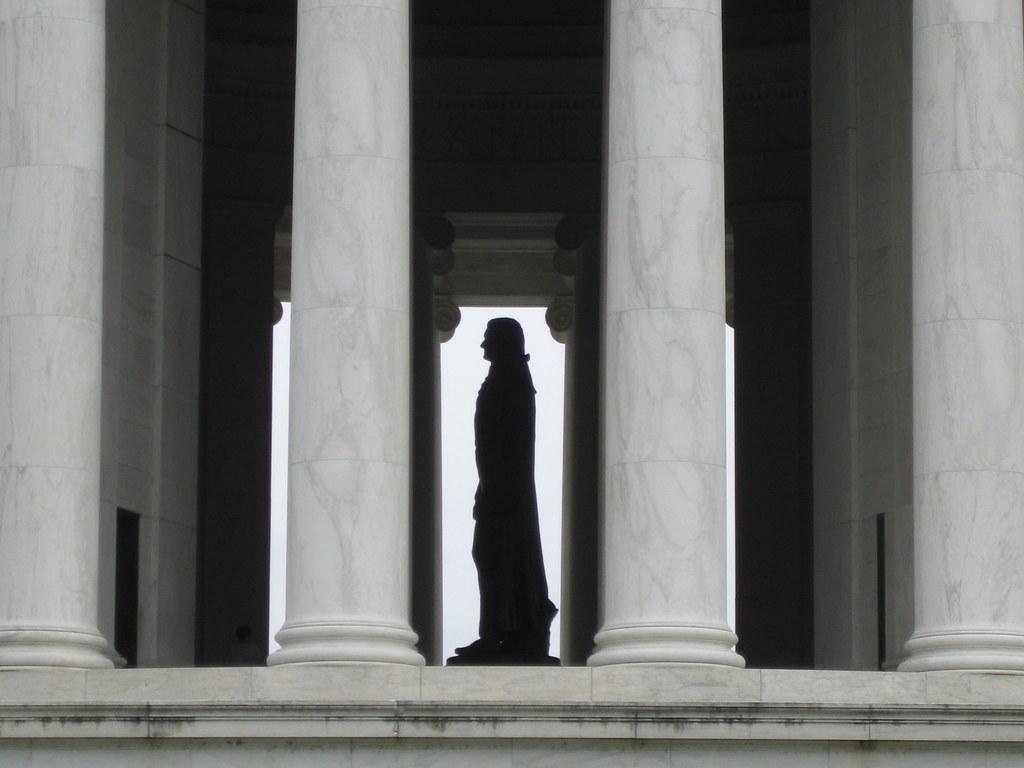Could you give a brief overview of what you see in this image? There are four white color pillars. In the back there is a statue. On the sides there are walls. 